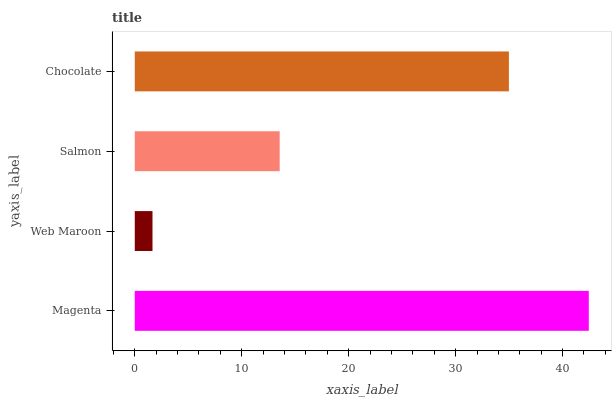Is Web Maroon the minimum?
Answer yes or no. Yes. Is Magenta the maximum?
Answer yes or no. Yes. Is Salmon the minimum?
Answer yes or no. No. Is Salmon the maximum?
Answer yes or no. No. Is Salmon greater than Web Maroon?
Answer yes or no. Yes. Is Web Maroon less than Salmon?
Answer yes or no. Yes. Is Web Maroon greater than Salmon?
Answer yes or no. No. Is Salmon less than Web Maroon?
Answer yes or no. No. Is Chocolate the high median?
Answer yes or no. Yes. Is Salmon the low median?
Answer yes or no. Yes. Is Web Maroon the high median?
Answer yes or no. No. Is Web Maroon the low median?
Answer yes or no. No. 